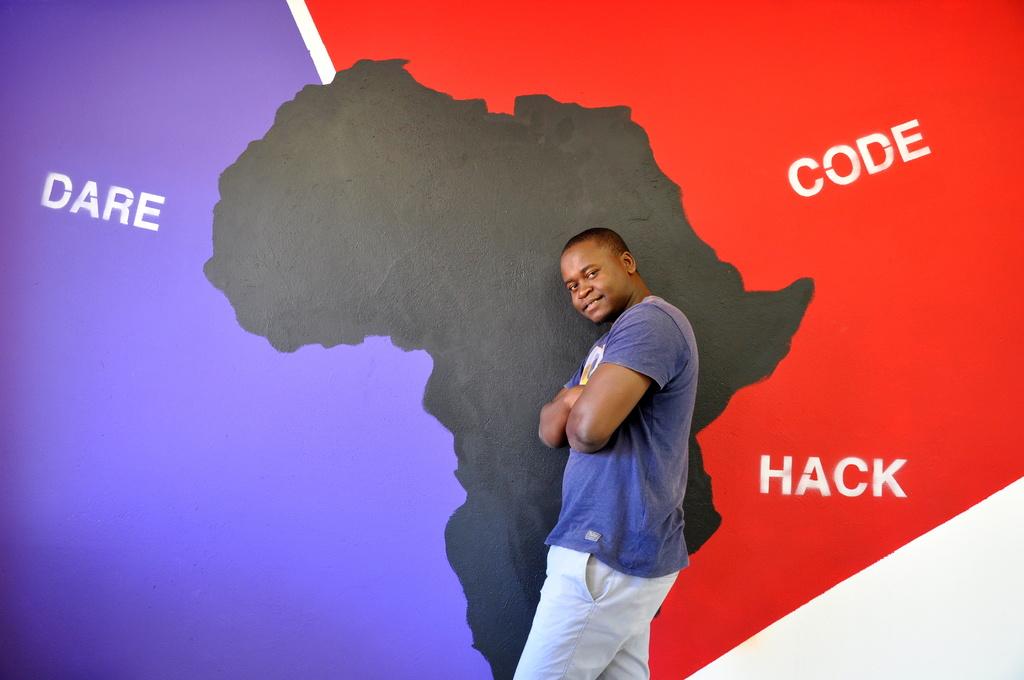What labels the purple color on the wall?
Keep it short and to the point. Dare. What illegal activity is this poster promoting?
Offer a very short reply. Hack. 